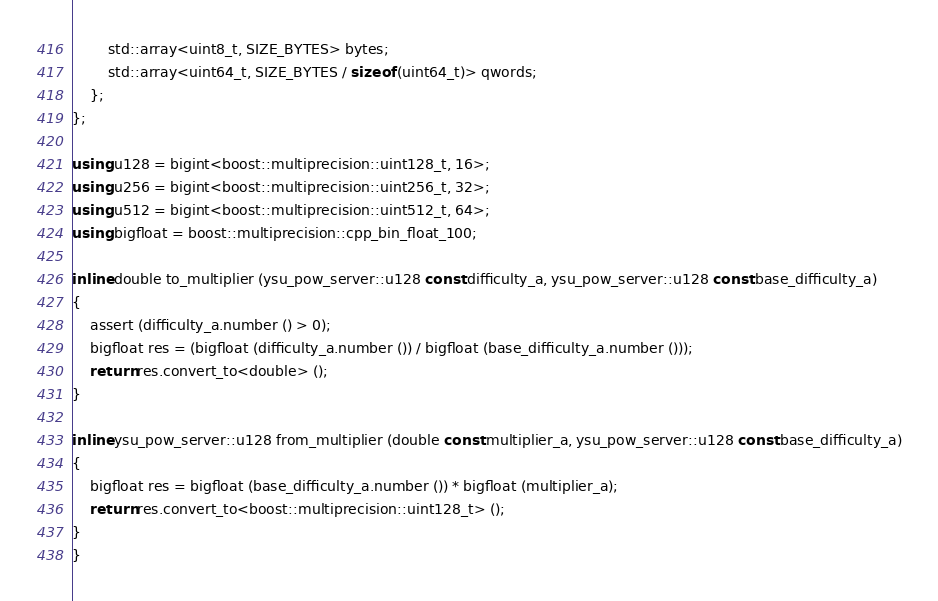Convert code to text. <code><loc_0><loc_0><loc_500><loc_500><_C++_>		std::array<uint8_t, SIZE_BYTES> bytes;
		std::array<uint64_t, SIZE_BYTES / sizeof (uint64_t)> qwords;
	};
};

using u128 = bigint<boost::multiprecision::uint128_t, 16>;
using u256 = bigint<boost::multiprecision::uint256_t, 32>;
using u512 = bigint<boost::multiprecision::uint512_t, 64>;
using bigfloat = boost::multiprecision::cpp_bin_float_100;

inline double to_multiplier (ysu_pow_server::u128 const difficulty_a, ysu_pow_server::u128 const base_difficulty_a)
{
	assert (difficulty_a.number () > 0);
	bigfloat res = (bigfloat (difficulty_a.number ()) / bigfloat (base_difficulty_a.number ()));
	return res.convert_to<double> ();
}

inline ysu_pow_server::u128 from_multiplier (double const multiplier_a, ysu_pow_server::u128 const base_difficulty_a)
{
	bigfloat res = bigfloat (base_difficulty_a.number ()) * bigfloat (multiplier_a);
	return res.convert_to<boost::multiprecision::uint128_t> ();
}
}
</code> 